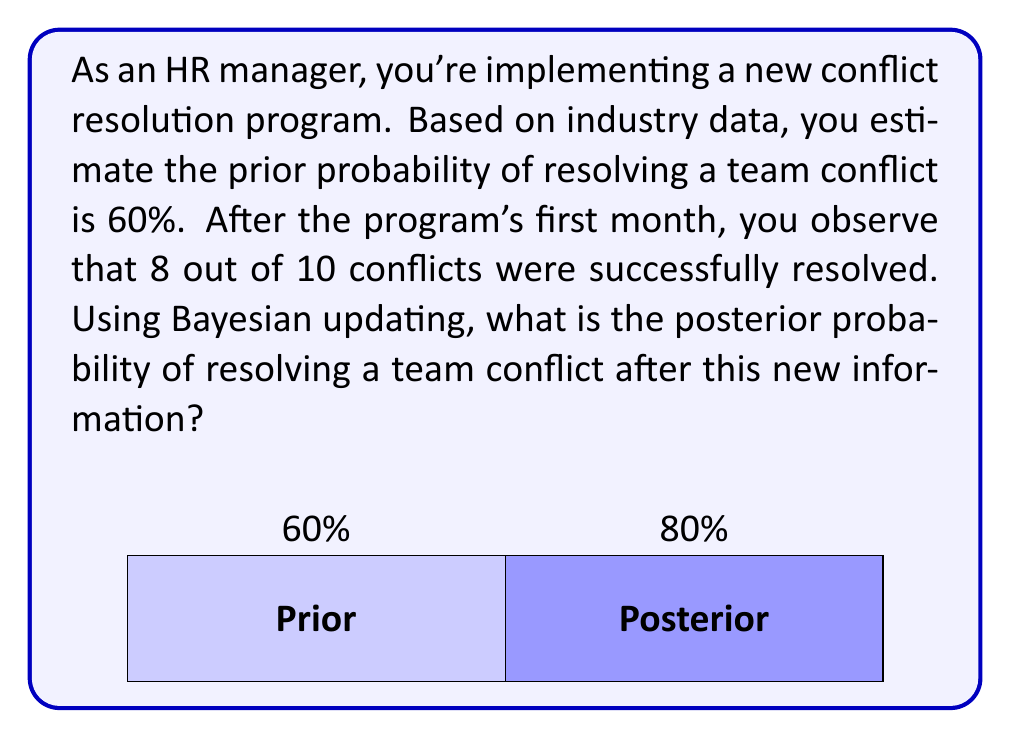Can you answer this question? To solve this problem using Bayesian updating, we'll follow these steps:

1) Define our variables:
   $P(A)$ = Prior probability of resolving a conflict = 0.60
   $P(B|A)$ = Likelihood of observing 8 out of 10 successes given the true probability is 0.60
   $P(B)$ = Overall probability of observing 8 out of 10 successes
   $P(A|B)$ = Posterior probability of resolving a conflict given our new data

2) We need to calculate $P(A|B)$ using Bayes' theorem:

   $$P(A|B) = \frac{P(B|A) \cdot P(A)}{P(B)}$$

3) Calculate $P(B|A)$ using the binomial probability formula:

   $$P(B|A) = \binom{10}{8} \cdot 0.60^8 \cdot 0.40^2 = 0.1211$$

4) Calculate $P(B)$ using the law of total probability:

   $$P(B) = P(B|A) \cdot P(A) + P(B|\text{not }A) \cdot P(\text{not }A)$$
   
   We need to calculate $P(B|\text{not }A)$:
   $$P(B|\text{not }A) = \binom{10}{8} \cdot 0.40^8 \cdot 0.60^2 = 0.0008$$

   Now we can calculate $P(B)$:
   $$P(B) = 0.1211 \cdot 0.60 + 0.0008 \cdot 0.40 = 0.0727$$

5) Now we have all components to calculate $P(A|B)$:

   $$P(A|B) = \frac{0.1211 \cdot 0.60}{0.0727} = 0.9988$$

Therefore, the posterior probability of resolving a team conflict after observing this new information is approximately 0.9988 or 99.88%.
Answer: $P(A|B) \approx 0.9988$ or 99.88% 